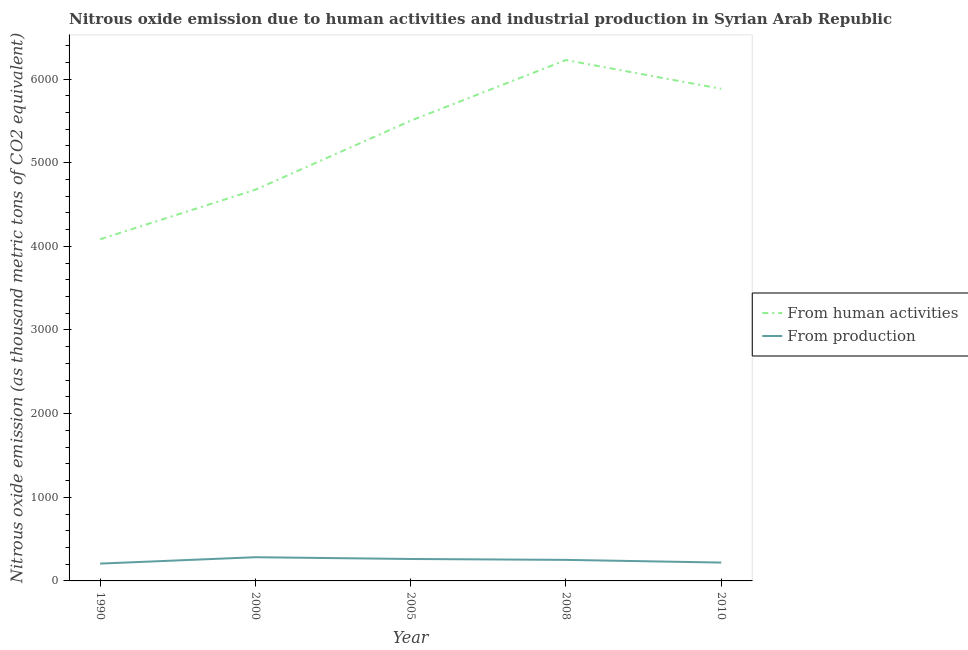How many different coloured lines are there?
Make the answer very short. 2. What is the amount of emissions generated from industries in 1990?
Your answer should be compact. 207.1. Across all years, what is the maximum amount of emissions generated from industries?
Your response must be concise. 283.3. Across all years, what is the minimum amount of emissions generated from industries?
Provide a short and direct response. 207.1. What is the total amount of emissions generated from industries in the graph?
Ensure brevity in your answer.  1223.8. What is the difference between the amount of emissions from human activities in 1990 and that in 2000?
Offer a very short reply. -592.5. What is the difference between the amount of emissions from human activities in 2008 and the amount of emissions generated from industries in 2000?
Ensure brevity in your answer.  5943.8. What is the average amount of emissions generated from industries per year?
Provide a succinct answer. 244.76. In the year 2010, what is the difference between the amount of emissions from human activities and amount of emissions generated from industries?
Your answer should be compact. 5663.6. In how many years, is the amount of emissions from human activities greater than 1200 thousand metric tons?
Your answer should be very brief. 5. What is the ratio of the amount of emissions from human activities in 2000 to that in 2010?
Offer a very short reply. 0.8. What is the difference between the highest and the second highest amount of emissions from human activities?
Keep it short and to the point. 344. What is the difference between the highest and the lowest amount of emissions generated from industries?
Your answer should be compact. 76.2. Does the amount of emissions generated from industries monotonically increase over the years?
Offer a terse response. No. Is the amount of emissions generated from industries strictly greater than the amount of emissions from human activities over the years?
Give a very brief answer. No. How many lines are there?
Offer a terse response. 2. What is the difference between two consecutive major ticks on the Y-axis?
Give a very brief answer. 1000. How many legend labels are there?
Keep it short and to the point. 2. How are the legend labels stacked?
Your response must be concise. Vertical. What is the title of the graph?
Give a very brief answer. Nitrous oxide emission due to human activities and industrial production in Syrian Arab Republic. What is the label or title of the X-axis?
Provide a short and direct response. Year. What is the label or title of the Y-axis?
Provide a succinct answer. Nitrous oxide emission (as thousand metric tons of CO2 equivalent). What is the Nitrous oxide emission (as thousand metric tons of CO2 equivalent) in From human activities in 1990?
Your answer should be compact. 4084.8. What is the Nitrous oxide emission (as thousand metric tons of CO2 equivalent) of From production in 1990?
Keep it short and to the point. 207.1. What is the Nitrous oxide emission (as thousand metric tons of CO2 equivalent) in From human activities in 2000?
Your answer should be very brief. 4677.3. What is the Nitrous oxide emission (as thousand metric tons of CO2 equivalent) of From production in 2000?
Ensure brevity in your answer.  283.3. What is the Nitrous oxide emission (as thousand metric tons of CO2 equivalent) of From human activities in 2005?
Offer a very short reply. 5502.2. What is the Nitrous oxide emission (as thousand metric tons of CO2 equivalent) of From production in 2005?
Provide a succinct answer. 262.2. What is the Nitrous oxide emission (as thousand metric tons of CO2 equivalent) of From human activities in 2008?
Your answer should be very brief. 6227.1. What is the Nitrous oxide emission (as thousand metric tons of CO2 equivalent) in From production in 2008?
Provide a succinct answer. 251.7. What is the Nitrous oxide emission (as thousand metric tons of CO2 equivalent) of From human activities in 2010?
Your response must be concise. 5883.1. What is the Nitrous oxide emission (as thousand metric tons of CO2 equivalent) of From production in 2010?
Offer a terse response. 219.5. Across all years, what is the maximum Nitrous oxide emission (as thousand metric tons of CO2 equivalent) in From human activities?
Offer a very short reply. 6227.1. Across all years, what is the maximum Nitrous oxide emission (as thousand metric tons of CO2 equivalent) of From production?
Your answer should be compact. 283.3. Across all years, what is the minimum Nitrous oxide emission (as thousand metric tons of CO2 equivalent) of From human activities?
Make the answer very short. 4084.8. Across all years, what is the minimum Nitrous oxide emission (as thousand metric tons of CO2 equivalent) of From production?
Offer a terse response. 207.1. What is the total Nitrous oxide emission (as thousand metric tons of CO2 equivalent) in From human activities in the graph?
Your answer should be very brief. 2.64e+04. What is the total Nitrous oxide emission (as thousand metric tons of CO2 equivalent) of From production in the graph?
Provide a succinct answer. 1223.8. What is the difference between the Nitrous oxide emission (as thousand metric tons of CO2 equivalent) of From human activities in 1990 and that in 2000?
Give a very brief answer. -592.5. What is the difference between the Nitrous oxide emission (as thousand metric tons of CO2 equivalent) of From production in 1990 and that in 2000?
Offer a very short reply. -76.2. What is the difference between the Nitrous oxide emission (as thousand metric tons of CO2 equivalent) in From human activities in 1990 and that in 2005?
Provide a succinct answer. -1417.4. What is the difference between the Nitrous oxide emission (as thousand metric tons of CO2 equivalent) in From production in 1990 and that in 2005?
Offer a very short reply. -55.1. What is the difference between the Nitrous oxide emission (as thousand metric tons of CO2 equivalent) in From human activities in 1990 and that in 2008?
Your response must be concise. -2142.3. What is the difference between the Nitrous oxide emission (as thousand metric tons of CO2 equivalent) of From production in 1990 and that in 2008?
Offer a very short reply. -44.6. What is the difference between the Nitrous oxide emission (as thousand metric tons of CO2 equivalent) of From human activities in 1990 and that in 2010?
Your answer should be very brief. -1798.3. What is the difference between the Nitrous oxide emission (as thousand metric tons of CO2 equivalent) in From human activities in 2000 and that in 2005?
Offer a terse response. -824.9. What is the difference between the Nitrous oxide emission (as thousand metric tons of CO2 equivalent) in From production in 2000 and that in 2005?
Your answer should be compact. 21.1. What is the difference between the Nitrous oxide emission (as thousand metric tons of CO2 equivalent) in From human activities in 2000 and that in 2008?
Provide a succinct answer. -1549.8. What is the difference between the Nitrous oxide emission (as thousand metric tons of CO2 equivalent) of From production in 2000 and that in 2008?
Your answer should be very brief. 31.6. What is the difference between the Nitrous oxide emission (as thousand metric tons of CO2 equivalent) in From human activities in 2000 and that in 2010?
Your answer should be compact. -1205.8. What is the difference between the Nitrous oxide emission (as thousand metric tons of CO2 equivalent) in From production in 2000 and that in 2010?
Ensure brevity in your answer.  63.8. What is the difference between the Nitrous oxide emission (as thousand metric tons of CO2 equivalent) in From human activities in 2005 and that in 2008?
Provide a succinct answer. -724.9. What is the difference between the Nitrous oxide emission (as thousand metric tons of CO2 equivalent) in From production in 2005 and that in 2008?
Provide a short and direct response. 10.5. What is the difference between the Nitrous oxide emission (as thousand metric tons of CO2 equivalent) of From human activities in 2005 and that in 2010?
Ensure brevity in your answer.  -380.9. What is the difference between the Nitrous oxide emission (as thousand metric tons of CO2 equivalent) of From production in 2005 and that in 2010?
Your answer should be compact. 42.7. What is the difference between the Nitrous oxide emission (as thousand metric tons of CO2 equivalent) of From human activities in 2008 and that in 2010?
Offer a terse response. 344. What is the difference between the Nitrous oxide emission (as thousand metric tons of CO2 equivalent) in From production in 2008 and that in 2010?
Offer a terse response. 32.2. What is the difference between the Nitrous oxide emission (as thousand metric tons of CO2 equivalent) in From human activities in 1990 and the Nitrous oxide emission (as thousand metric tons of CO2 equivalent) in From production in 2000?
Give a very brief answer. 3801.5. What is the difference between the Nitrous oxide emission (as thousand metric tons of CO2 equivalent) of From human activities in 1990 and the Nitrous oxide emission (as thousand metric tons of CO2 equivalent) of From production in 2005?
Ensure brevity in your answer.  3822.6. What is the difference between the Nitrous oxide emission (as thousand metric tons of CO2 equivalent) of From human activities in 1990 and the Nitrous oxide emission (as thousand metric tons of CO2 equivalent) of From production in 2008?
Offer a very short reply. 3833.1. What is the difference between the Nitrous oxide emission (as thousand metric tons of CO2 equivalent) in From human activities in 1990 and the Nitrous oxide emission (as thousand metric tons of CO2 equivalent) in From production in 2010?
Ensure brevity in your answer.  3865.3. What is the difference between the Nitrous oxide emission (as thousand metric tons of CO2 equivalent) of From human activities in 2000 and the Nitrous oxide emission (as thousand metric tons of CO2 equivalent) of From production in 2005?
Your answer should be compact. 4415.1. What is the difference between the Nitrous oxide emission (as thousand metric tons of CO2 equivalent) in From human activities in 2000 and the Nitrous oxide emission (as thousand metric tons of CO2 equivalent) in From production in 2008?
Ensure brevity in your answer.  4425.6. What is the difference between the Nitrous oxide emission (as thousand metric tons of CO2 equivalent) of From human activities in 2000 and the Nitrous oxide emission (as thousand metric tons of CO2 equivalent) of From production in 2010?
Ensure brevity in your answer.  4457.8. What is the difference between the Nitrous oxide emission (as thousand metric tons of CO2 equivalent) in From human activities in 2005 and the Nitrous oxide emission (as thousand metric tons of CO2 equivalent) in From production in 2008?
Your answer should be compact. 5250.5. What is the difference between the Nitrous oxide emission (as thousand metric tons of CO2 equivalent) in From human activities in 2005 and the Nitrous oxide emission (as thousand metric tons of CO2 equivalent) in From production in 2010?
Your answer should be very brief. 5282.7. What is the difference between the Nitrous oxide emission (as thousand metric tons of CO2 equivalent) in From human activities in 2008 and the Nitrous oxide emission (as thousand metric tons of CO2 equivalent) in From production in 2010?
Provide a short and direct response. 6007.6. What is the average Nitrous oxide emission (as thousand metric tons of CO2 equivalent) of From human activities per year?
Give a very brief answer. 5274.9. What is the average Nitrous oxide emission (as thousand metric tons of CO2 equivalent) of From production per year?
Offer a very short reply. 244.76. In the year 1990, what is the difference between the Nitrous oxide emission (as thousand metric tons of CO2 equivalent) of From human activities and Nitrous oxide emission (as thousand metric tons of CO2 equivalent) of From production?
Give a very brief answer. 3877.7. In the year 2000, what is the difference between the Nitrous oxide emission (as thousand metric tons of CO2 equivalent) of From human activities and Nitrous oxide emission (as thousand metric tons of CO2 equivalent) of From production?
Your answer should be very brief. 4394. In the year 2005, what is the difference between the Nitrous oxide emission (as thousand metric tons of CO2 equivalent) in From human activities and Nitrous oxide emission (as thousand metric tons of CO2 equivalent) in From production?
Ensure brevity in your answer.  5240. In the year 2008, what is the difference between the Nitrous oxide emission (as thousand metric tons of CO2 equivalent) in From human activities and Nitrous oxide emission (as thousand metric tons of CO2 equivalent) in From production?
Offer a very short reply. 5975.4. In the year 2010, what is the difference between the Nitrous oxide emission (as thousand metric tons of CO2 equivalent) in From human activities and Nitrous oxide emission (as thousand metric tons of CO2 equivalent) in From production?
Provide a short and direct response. 5663.6. What is the ratio of the Nitrous oxide emission (as thousand metric tons of CO2 equivalent) of From human activities in 1990 to that in 2000?
Ensure brevity in your answer.  0.87. What is the ratio of the Nitrous oxide emission (as thousand metric tons of CO2 equivalent) in From production in 1990 to that in 2000?
Give a very brief answer. 0.73. What is the ratio of the Nitrous oxide emission (as thousand metric tons of CO2 equivalent) in From human activities in 1990 to that in 2005?
Provide a short and direct response. 0.74. What is the ratio of the Nitrous oxide emission (as thousand metric tons of CO2 equivalent) in From production in 1990 to that in 2005?
Your answer should be compact. 0.79. What is the ratio of the Nitrous oxide emission (as thousand metric tons of CO2 equivalent) of From human activities in 1990 to that in 2008?
Offer a terse response. 0.66. What is the ratio of the Nitrous oxide emission (as thousand metric tons of CO2 equivalent) of From production in 1990 to that in 2008?
Provide a succinct answer. 0.82. What is the ratio of the Nitrous oxide emission (as thousand metric tons of CO2 equivalent) in From human activities in 1990 to that in 2010?
Make the answer very short. 0.69. What is the ratio of the Nitrous oxide emission (as thousand metric tons of CO2 equivalent) of From production in 1990 to that in 2010?
Keep it short and to the point. 0.94. What is the ratio of the Nitrous oxide emission (as thousand metric tons of CO2 equivalent) in From human activities in 2000 to that in 2005?
Your response must be concise. 0.85. What is the ratio of the Nitrous oxide emission (as thousand metric tons of CO2 equivalent) in From production in 2000 to that in 2005?
Your answer should be very brief. 1.08. What is the ratio of the Nitrous oxide emission (as thousand metric tons of CO2 equivalent) in From human activities in 2000 to that in 2008?
Your response must be concise. 0.75. What is the ratio of the Nitrous oxide emission (as thousand metric tons of CO2 equivalent) in From production in 2000 to that in 2008?
Your response must be concise. 1.13. What is the ratio of the Nitrous oxide emission (as thousand metric tons of CO2 equivalent) in From human activities in 2000 to that in 2010?
Provide a short and direct response. 0.8. What is the ratio of the Nitrous oxide emission (as thousand metric tons of CO2 equivalent) in From production in 2000 to that in 2010?
Ensure brevity in your answer.  1.29. What is the ratio of the Nitrous oxide emission (as thousand metric tons of CO2 equivalent) in From human activities in 2005 to that in 2008?
Your answer should be compact. 0.88. What is the ratio of the Nitrous oxide emission (as thousand metric tons of CO2 equivalent) in From production in 2005 to that in 2008?
Make the answer very short. 1.04. What is the ratio of the Nitrous oxide emission (as thousand metric tons of CO2 equivalent) in From human activities in 2005 to that in 2010?
Offer a very short reply. 0.94. What is the ratio of the Nitrous oxide emission (as thousand metric tons of CO2 equivalent) of From production in 2005 to that in 2010?
Ensure brevity in your answer.  1.19. What is the ratio of the Nitrous oxide emission (as thousand metric tons of CO2 equivalent) in From human activities in 2008 to that in 2010?
Offer a terse response. 1.06. What is the ratio of the Nitrous oxide emission (as thousand metric tons of CO2 equivalent) of From production in 2008 to that in 2010?
Your answer should be very brief. 1.15. What is the difference between the highest and the second highest Nitrous oxide emission (as thousand metric tons of CO2 equivalent) of From human activities?
Provide a short and direct response. 344. What is the difference between the highest and the second highest Nitrous oxide emission (as thousand metric tons of CO2 equivalent) of From production?
Your answer should be compact. 21.1. What is the difference between the highest and the lowest Nitrous oxide emission (as thousand metric tons of CO2 equivalent) in From human activities?
Give a very brief answer. 2142.3. What is the difference between the highest and the lowest Nitrous oxide emission (as thousand metric tons of CO2 equivalent) of From production?
Provide a short and direct response. 76.2. 